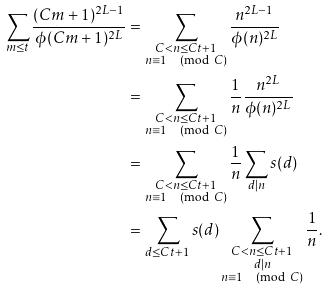<formula> <loc_0><loc_0><loc_500><loc_500>\sum _ { m \leq t } \frac { ( C m + 1 ) ^ { 2 L - 1 } } { \phi ( C m + 1 ) ^ { 2 L } } & = \sum _ { \substack { C < n \leq C t + 1 \\ n \equiv 1 \pmod { C } } } \frac { n ^ { 2 L - 1 } } { \phi ( n ) ^ { 2 L } } \\ & = \sum _ { \substack { C < n \leq C t + 1 \\ n \equiv 1 \pmod { C } } } \frac { 1 } { n } \frac { n ^ { 2 L } } { \phi ( n ) ^ { 2 L } } \\ & = \sum _ { \substack { C < n \leq C t + 1 \\ n \equiv 1 \pmod { C } } } \frac { 1 } { n } \sum _ { d | n } s ( d ) \\ & = \sum _ { d \leq C t + 1 } s ( d ) \sum _ { \substack { C < n \leq C t + 1 \\ d | n \\ n \equiv 1 \pmod { C } } } \frac { 1 } { n } .</formula> 